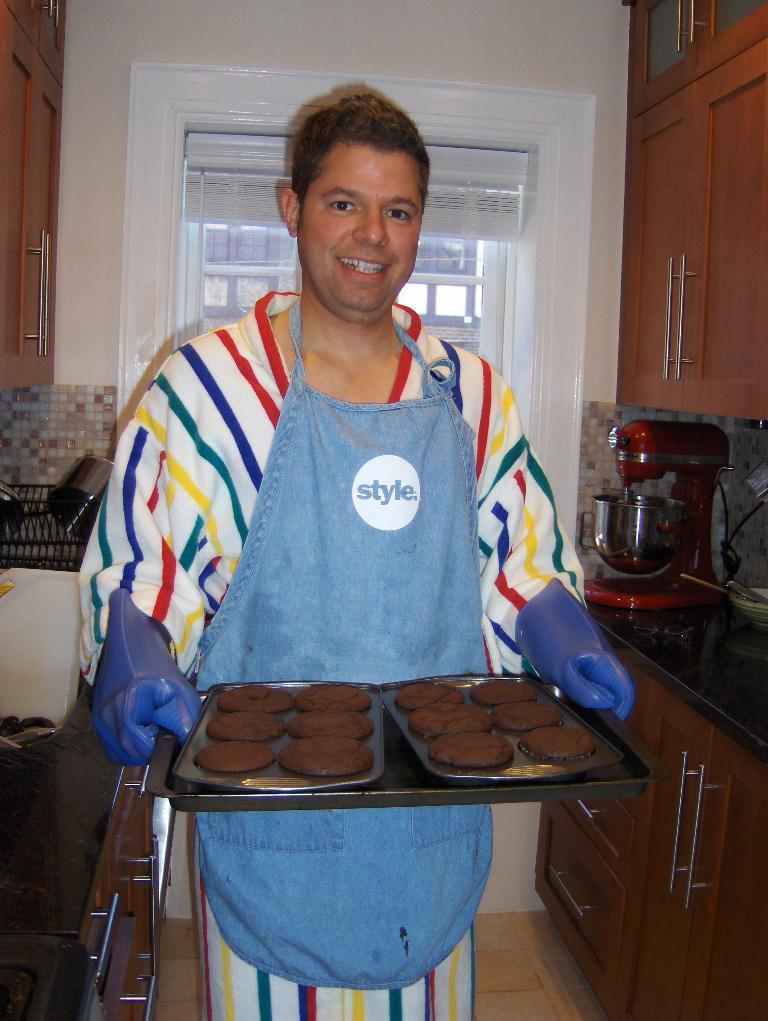What is the word on shirt?
Your answer should be compact. Style. 